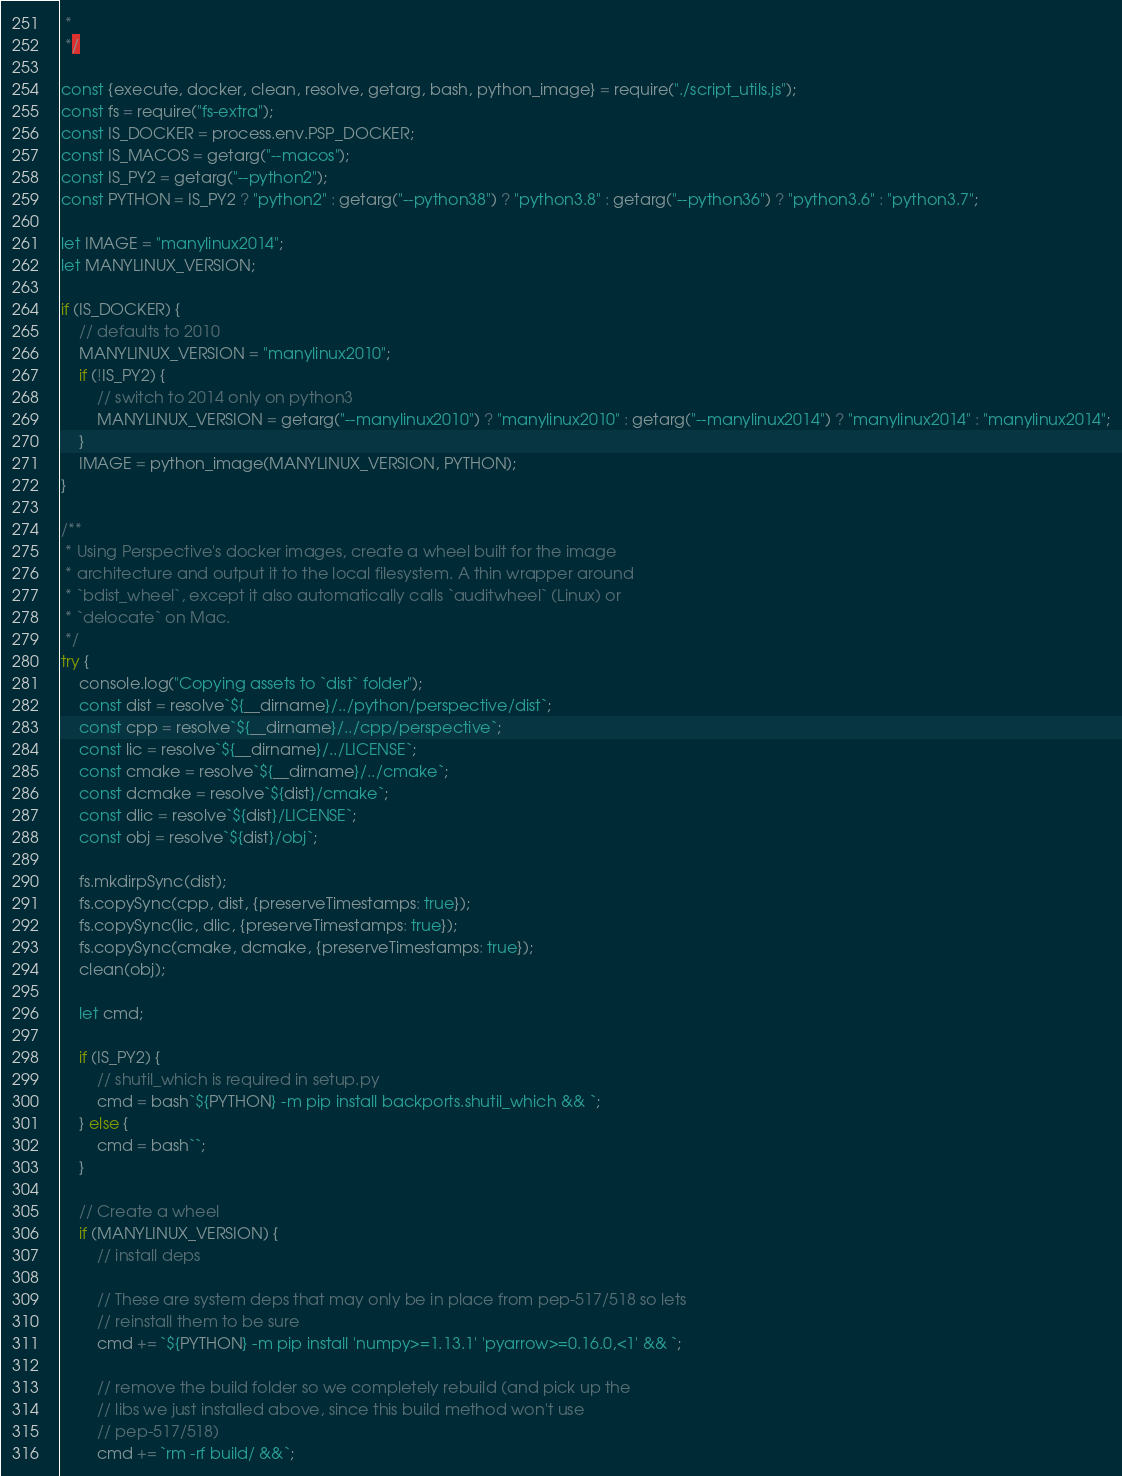Convert code to text. <code><loc_0><loc_0><loc_500><loc_500><_JavaScript_> *
 */

const {execute, docker, clean, resolve, getarg, bash, python_image} = require("./script_utils.js");
const fs = require("fs-extra");
const IS_DOCKER = process.env.PSP_DOCKER;
const IS_MACOS = getarg("--macos");
const IS_PY2 = getarg("--python2");
const PYTHON = IS_PY2 ? "python2" : getarg("--python38") ? "python3.8" : getarg("--python36") ? "python3.6" : "python3.7";

let IMAGE = "manylinux2014";
let MANYLINUX_VERSION;

if (IS_DOCKER) {
    // defaults to 2010
    MANYLINUX_VERSION = "manylinux2010";
    if (!IS_PY2) {
        // switch to 2014 only on python3
        MANYLINUX_VERSION = getarg("--manylinux2010") ? "manylinux2010" : getarg("--manylinux2014") ? "manylinux2014" : "manylinux2014";
    }
    IMAGE = python_image(MANYLINUX_VERSION, PYTHON);
}

/**
 * Using Perspective's docker images, create a wheel built for the image
 * architecture and output it to the local filesystem. A thin wrapper around
 * `bdist_wheel`, except it also automatically calls `auditwheel` (Linux) or
 * `delocate` on Mac.
 */
try {
    console.log("Copying assets to `dist` folder");
    const dist = resolve`${__dirname}/../python/perspective/dist`;
    const cpp = resolve`${__dirname}/../cpp/perspective`;
    const lic = resolve`${__dirname}/../LICENSE`;
    const cmake = resolve`${__dirname}/../cmake`;
    const dcmake = resolve`${dist}/cmake`;
    const dlic = resolve`${dist}/LICENSE`;
    const obj = resolve`${dist}/obj`;

    fs.mkdirpSync(dist);
    fs.copySync(cpp, dist, {preserveTimestamps: true});
    fs.copySync(lic, dlic, {preserveTimestamps: true});
    fs.copySync(cmake, dcmake, {preserveTimestamps: true});
    clean(obj);

    let cmd;

    if (IS_PY2) {
        // shutil_which is required in setup.py
        cmd = bash`${PYTHON} -m pip install backports.shutil_which && `;
    } else {
        cmd = bash``;
    }

    // Create a wheel
    if (MANYLINUX_VERSION) {
        // install deps
        
        // These are system deps that may only be in place from pep-517/518 so lets
        // reinstall them to be sure
        cmd += `${PYTHON} -m pip install 'numpy>=1.13.1' 'pyarrow>=0.16.0,<1' && `;

        // remove the build folder so we completely rebuild (and pick up the 
        // libs we just installed above, since this build method won't use
        // pep-517/518)
        cmd += `rm -rf build/ &&`;
</code> 